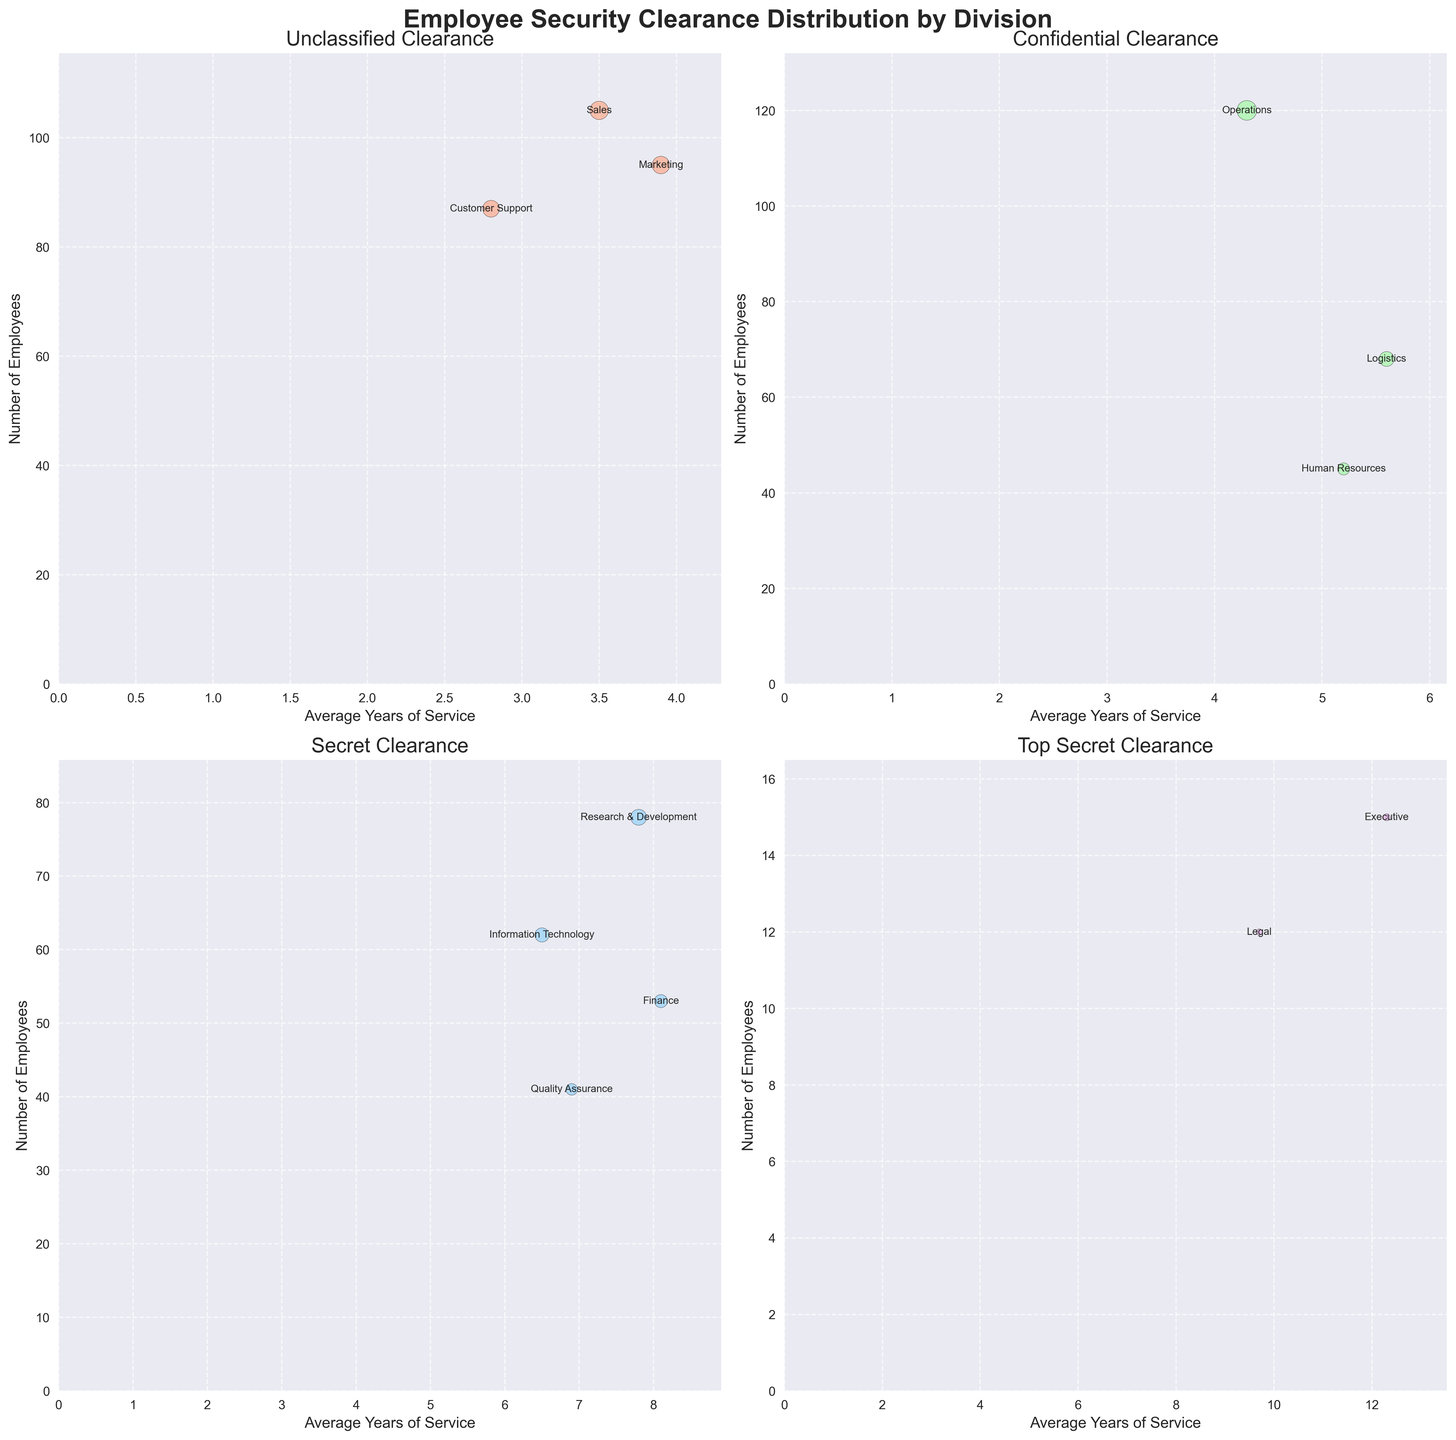What is the title of the figure? The title of the figure is generally placed at the top and is meant to provide a summary of what the figure is about. Here, the title is easily found in bold, larger font above the charts.
Answer: Employee Security Clearance Distribution by Division How many clearance levels are depicted in the figure? The figure has subplots that break the data into groups based on clearance levels. There are four subplots, indicating the number of clearance levels.
Answer: Four Which division has the highest number of employees with Secret clearance? For the Secret clearance subplot, the y-axis indicates the number of employees. The highest point on this axis would represent the division with the most employees with Secret clearance. Here, the tallest bubble is the one labeled 'Research & Development'.
Answer: Research & Development What is the average years of service for employees in the Executive division with Top Secret clearance? In the Top Secret subplot, locate the bubble labeled 'Executive'. The x-axis represents the average years of service, which can be read directly below this bubble.
Answer: 12.3 years Compare the number of employees in the Logistics division with Confidential clearance to those in the Legal division with Top Secret clearance. Which is higher? Look at the two subplots: Confidential for Logistics and Top Secret for Legal. Compare the y-axis values for both divisions. Logistics has 68 employees, whereas Legal has 12 employees.
Answer: Logistics Does the average years of service for Top Secret clearance employees generally seem to be higher or lower than those with Unclassified clearance? Compare the x-axis values of the bubbles in the Top Secret and Unclassified subplots. The bubbles in the Top Secret subplot are farther to the right, indicating higher average years of service.
Answer: Higher Which division has the lowest number of employees with Unclassified clearance? In the Unclassified subplot, examine the y-axis values to find the smallest value. The smallest bubble is labeled 'Customer Support' with 87 employees.
Answer: Customer Support What is the approximate range of average years of service for employees in the Secret clearance subplot? In the Secret subplot, the average years of service is indicated on the x-axis. Find the minimum and maximum values that the bubbles span across. They range approximately from 6.5 to 8.1 years.
Answer: 6.5 to 8.1 years Which division has the most employees with Confidential clearance, and how many employees does it have? In the Confidential subplot, the y-axis shows employee count. The highest bubble in this subplot is 'Operations', indicating it has the most employees. The y-axis value for 'Operations' is 120.
Answer: Operations, 120 employees 